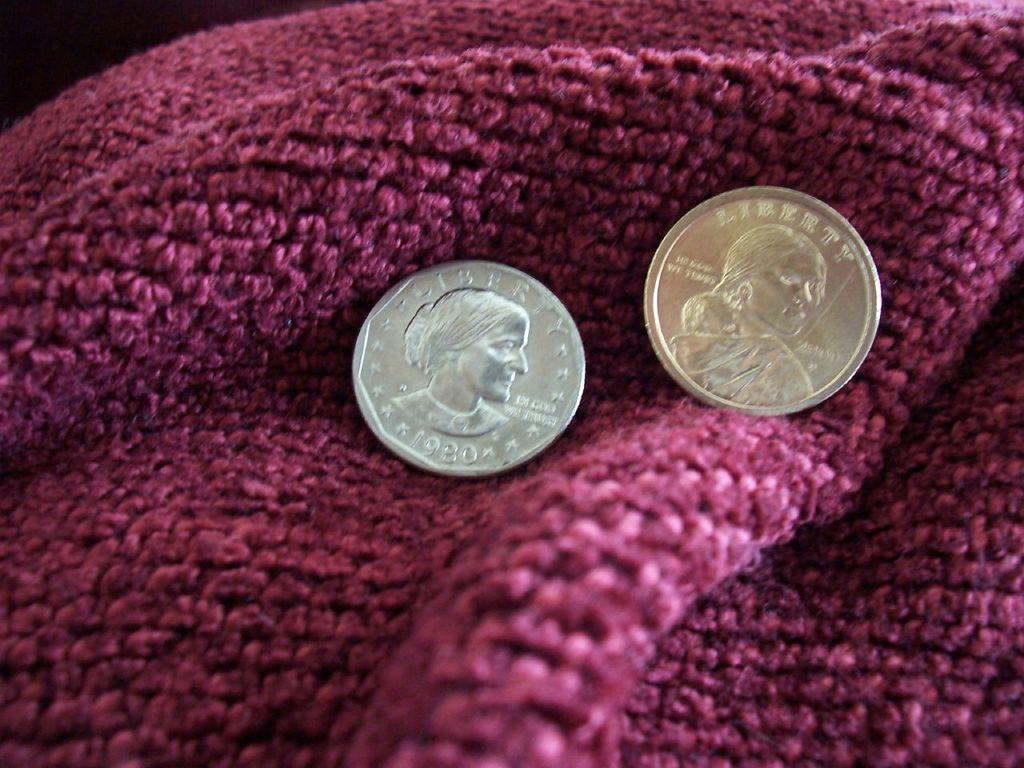What year is the silver colored coin?
Your response must be concise. 1980. 